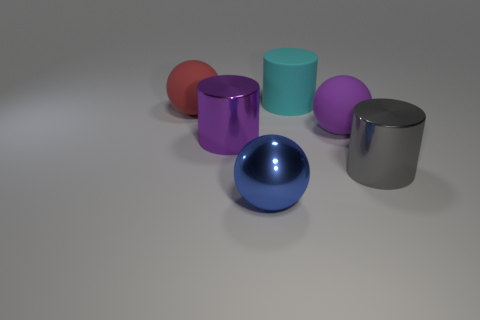There is a metal cylinder that is to the right of the large cyan rubber object that is behind the big matte ball that is behind the big purple ball; what is its color?
Offer a terse response. Gray. There is a large metallic cylinder that is to the left of the purple matte sphere; what number of metal things are in front of it?
Make the answer very short. 2. How many objects are matte things or big things that are on the left side of the large gray cylinder?
Your response must be concise. 5. Is the number of big rubber balls in front of the big red rubber sphere greater than the number of purple metal cylinders in front of the big blue metallic ball?
Provide a short and direct response. Yes. There is a large thing that is in front of the gray shiny object that is right of the matte thing in front of the big red rubber object; what shape is it?
Make the answer very short. Sphere. The metallic object that is on the right side of the cylinder behind the purple cylinder is what shape?
Provide a short and direct response. Cylinder. Are there any cyan cylinders that have the same material as the large purple sphere?
Your answer should be very brief. Yes. What number of gray things are small metallic objects or metal things?
Ensure brevity in your answer.  1. There is a gray cylinder that is made of the same material as the blue object; what size is it?
Provide a succinct answer. Large. How many blocks are either red rubber things or yellow objects?
Provide a succinct answer. 0. 